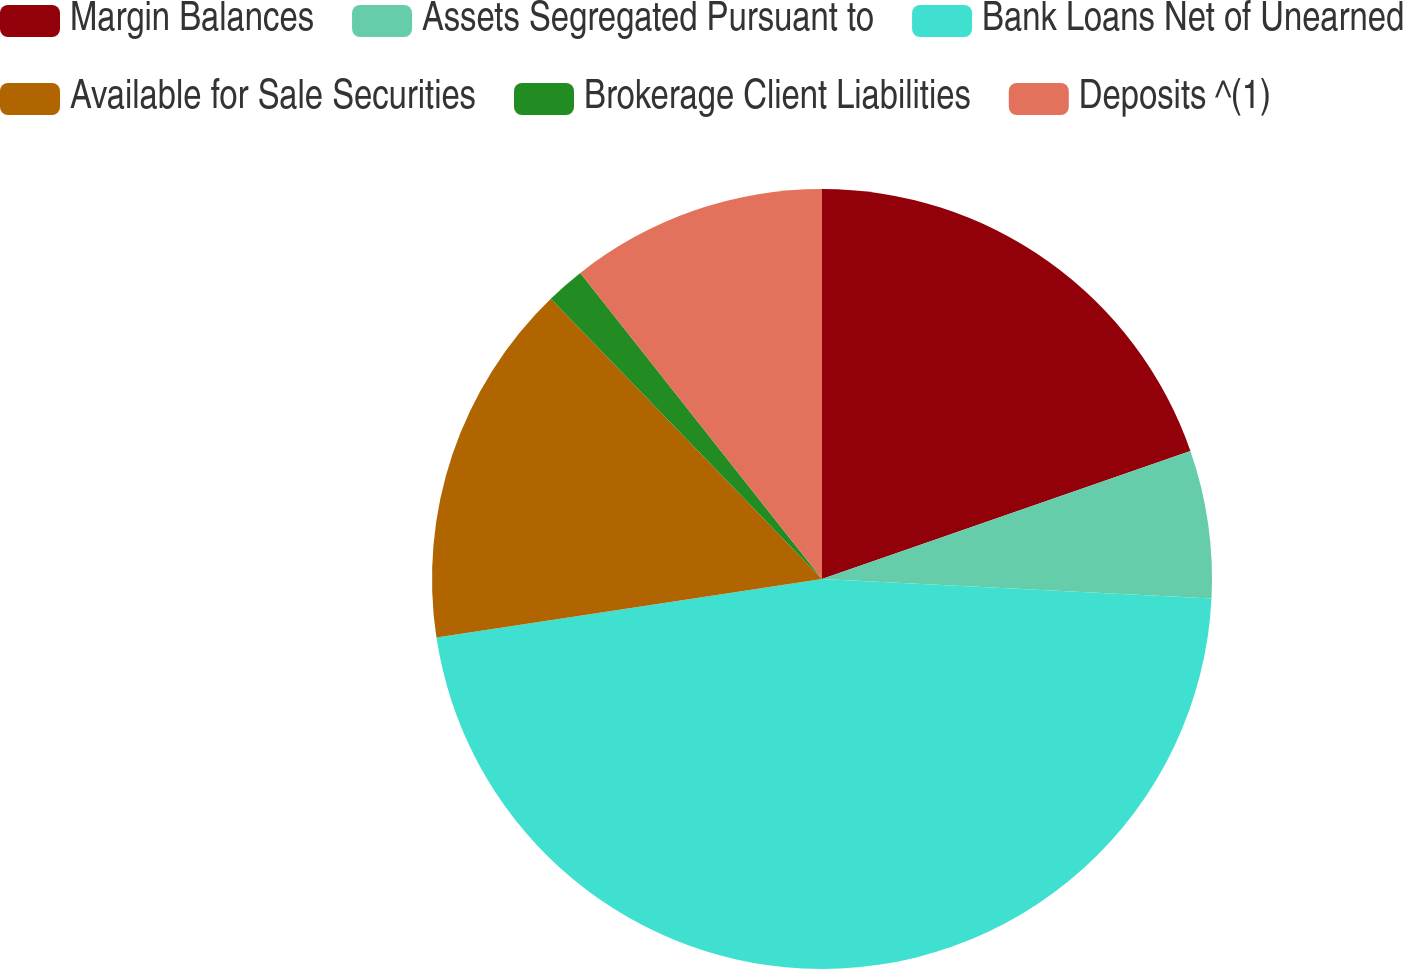<chart> <loc_0><loc_0><loc_500><loc_500><pie_chart><fcel>Margin Balances<fcel>Assets Segregated Pursuant to<fcel>Bank Loans Net of Unearned<fcel>Available for Sale Securities<fcel>Brokerage Client Liabilities<fcel>Deposits ^(1)<nl><fcel>19.68%<fcel>6.12%<fcel>46.8%<fcel>15.16%<fcel>1.6%<fcel>10.64%<nl></chart> 